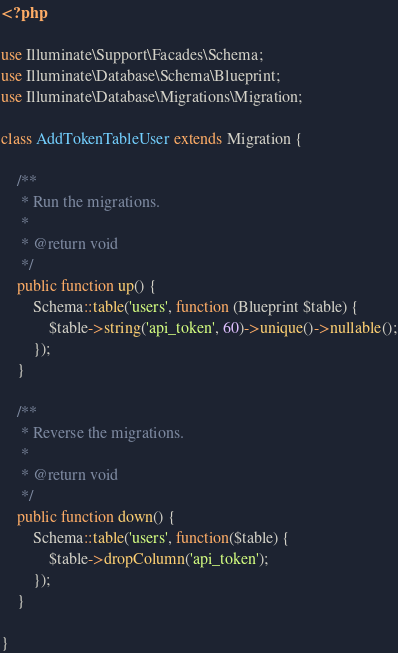Convert code to text. <code><loc_0><loc_0><loc_500><loc_500><_PHP_><?php

use Illuminate\Support\Facades\Schema;
use Illuminate\Database\Schema\Blueprint;
use Illuminate\Database\Migrations\Migration;

class AddTokenTableUser extends Migration {

    /**
     * Run the migrations.
     *
     * @return void
     */
    public function up() {
        Schema::table('users', function (Blueprint $table) {
            $table->string('api_token', 60)->unique()->nullable();
        });
    }

    /**
     * Reverse the migrations.
     *
     * @return void
     */
    public function down() {
        Schema::table('users', function($table) {
            $table->dropColumn('api_token');
        });
    }

}
</code> 